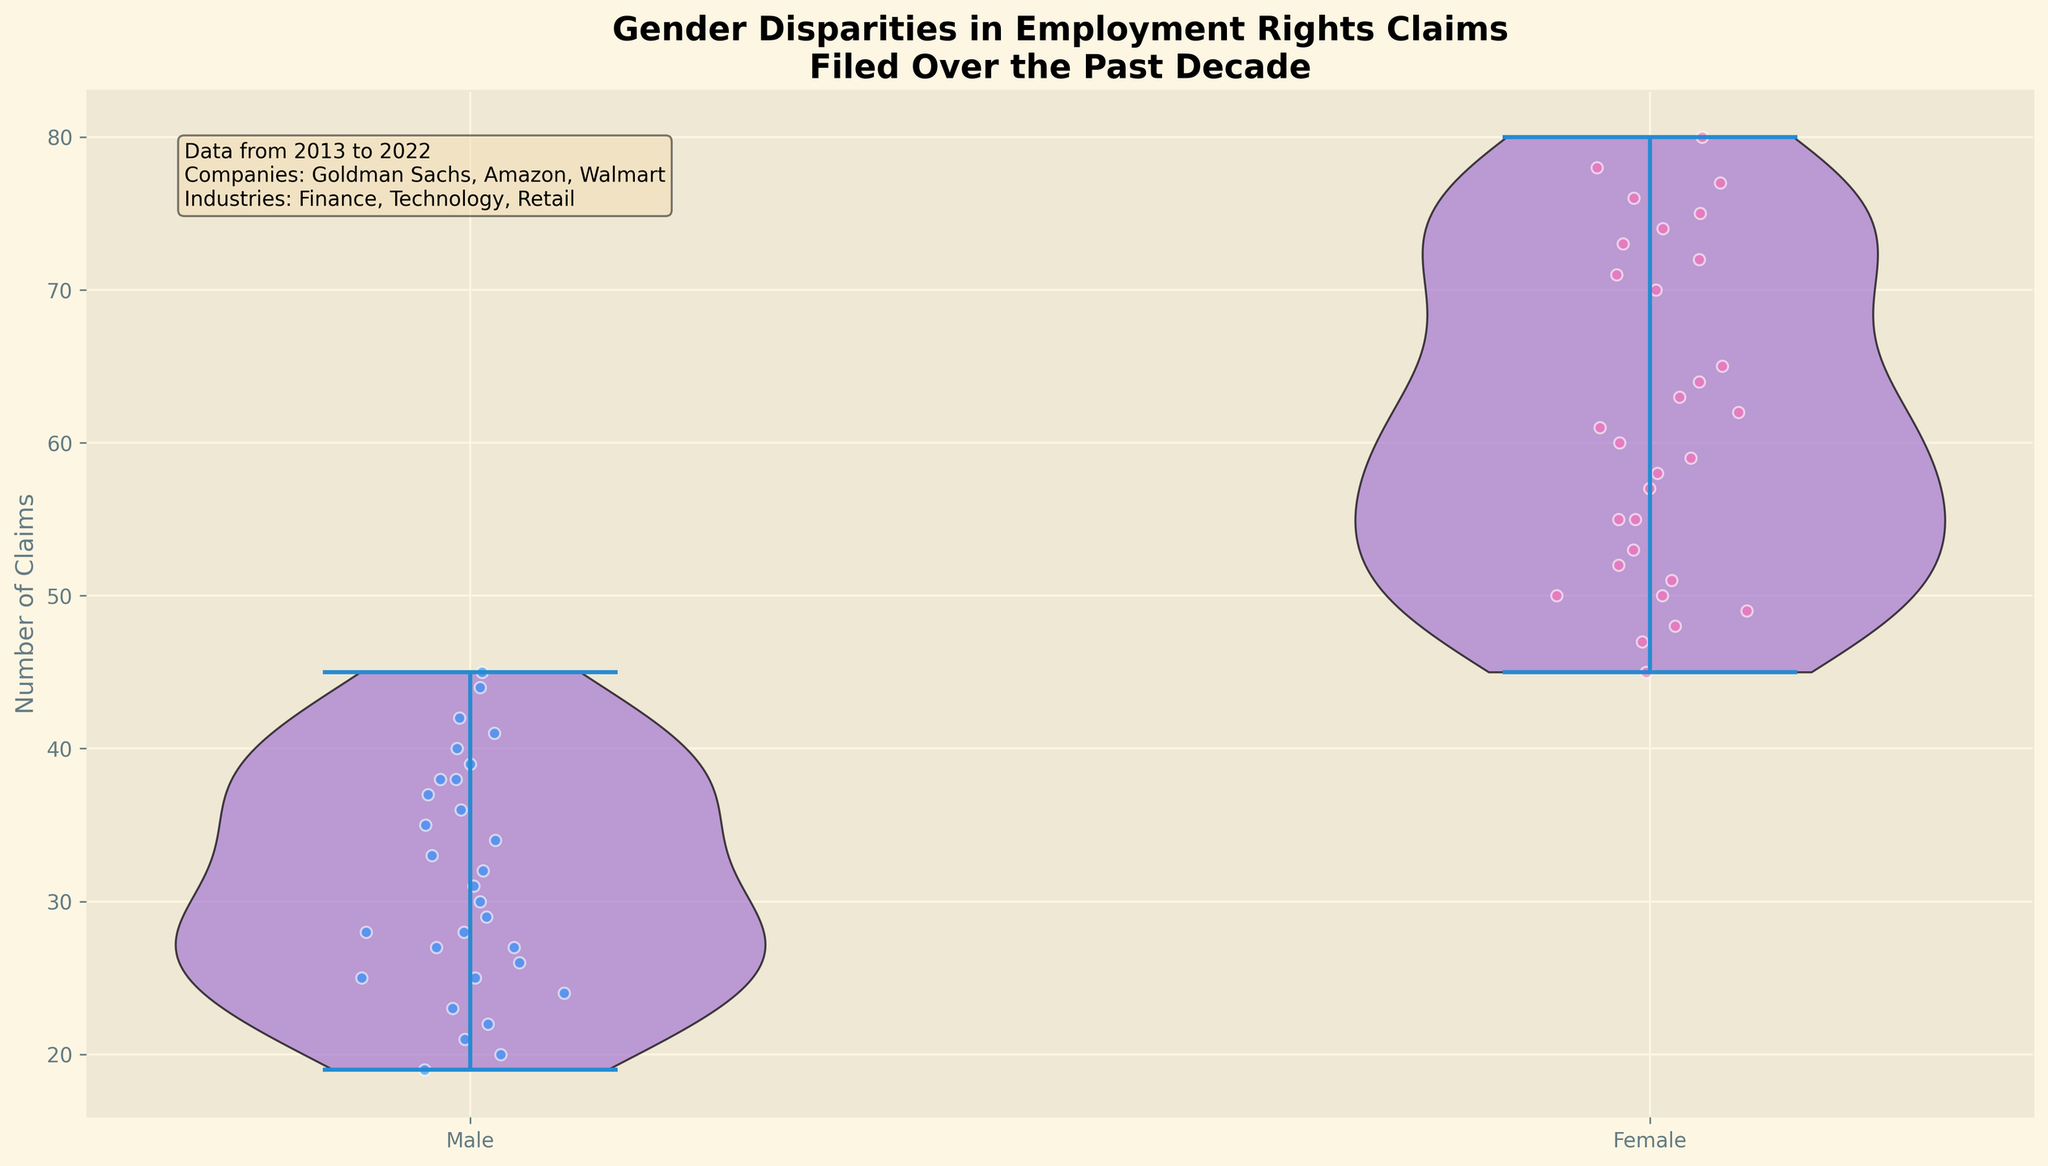What is the title of the figure? The title is typically shown at the top of the figure. It gives a brief summary of what the chart depicts. Here, the title is mentioned at the top of the plot.
Answer: Gender Disparities in Employment Rights Claims Filed Over the Past Decade What are the labels for the x-axis and y-axis? The x-axis usually shows the categories being compared, and the y-axis shows the quantity measured. Here, the x-axis labels 'Male' and 'Female', while the y-axis is labeled 'Number of Claims'.
Answer: x-axis: Male, Female; y-axis: Number of Claims How many colors are used to represent the data, and what are they? The colors can be observed in the violin plots and scatter points. Here, 'blue' is used for Male data points, and 'pink' is used for Female data points.
Answer: Two colors: blue and pink How many total data points are plotted for the Male and Female groups combined? Count the number of points scattered across both the Male and Female categories. Each scatter point represents a data entry. By looking at the dots and counting, one can get the exact count.
Answer: 60 Which gender had a higher number of claims in 2015 for Walmart? By observing the jittered points and their median values on the y-axis for the year 2015, one can compare the values between Male and Female categories specifically for Walmart. The Female category appears higher.
Answer: Female What is the approximate range of claims for females? The range can be estimated by looking at the highest and lowest points within the Female violin plot. It spans from the minimum to maximum values among the scatter points.
Answer: Approx. 45 to 80 How do the distributions of claims differ between males and females? Observing the shape and spread of the violin plots, we can compare the distributions. Female claims show a broader and longer violin indicating higher variability and counts, while Male claims are more compressed and lower overall.
Answer: Females have broader and higher values What is the difference in median number of claims between males and females? Identify the median line within each violin plot, then estimate the median values for both genders. Subtract the male median from the female median to find the difference.
Answer: Approx. 53 - 31 = 22 On average, which gender has more filed claims in the Finance industry? Look at the scatter points specific to 'Goldman Sachs' as it represents the Finance industry. Compare the average position of Male versus Female points. Females typically lie higher.
Answer: Female 